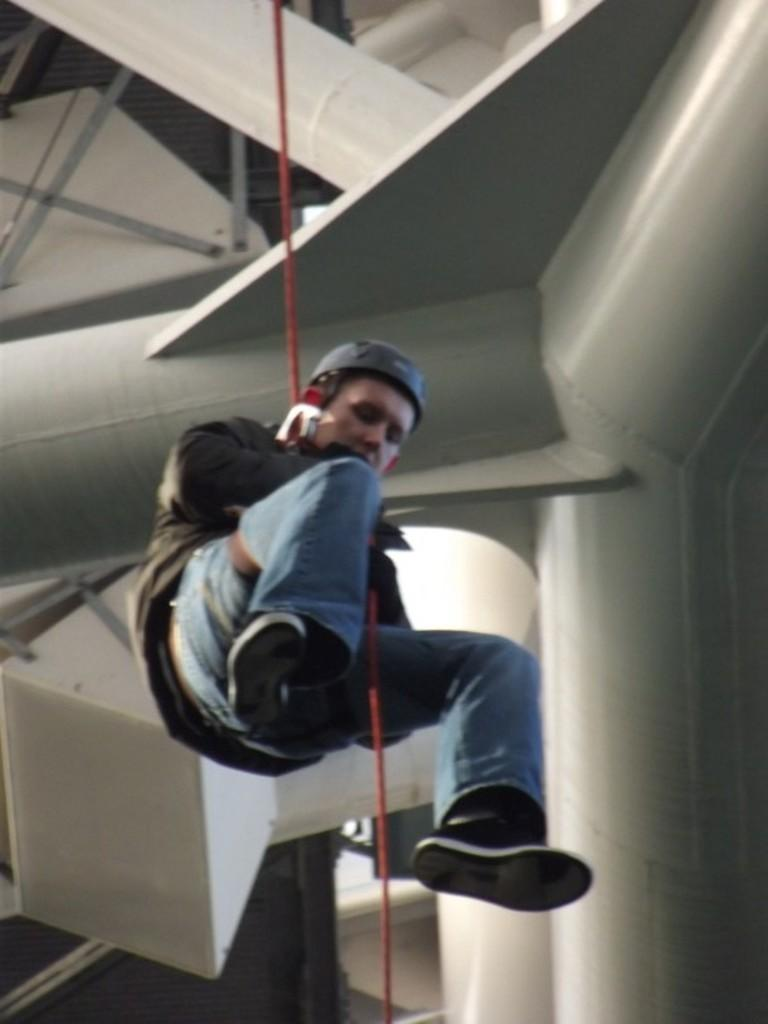What is the main subject of the image? There is a man in the image. What is the man doing in the image? The man is hanging on a rope. What can be seen in the background of the image? There is a building in the background of the image. What type of instrument is the man playing while hanging on the rope? There is no instrument present in the image, and the man is not playing any instrument while hanging on the rope. 